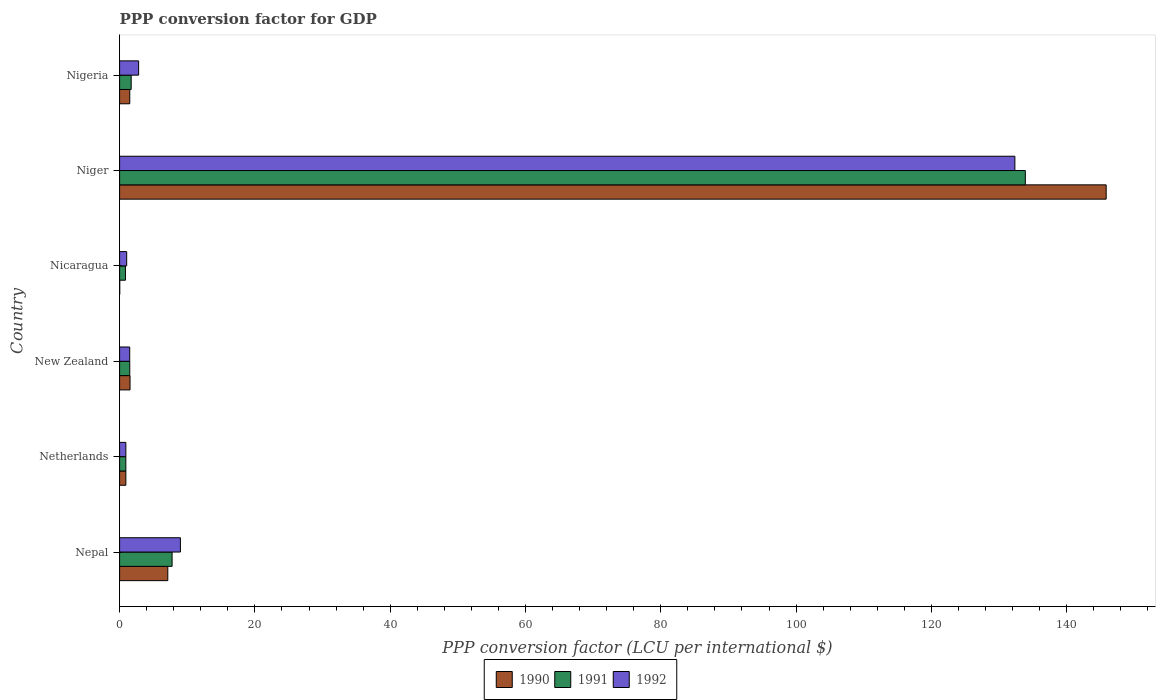How many different coloured bars are there?
Provide a short and direct response. 3. How many groups of bars are there?
Provide a succinct answer. 6. Are the number of bars on each tick of the Y-axis equal?
Keep it short and to the point. Yes. How many bars are there on the 2nd tick from the top?
Provide a short and direct response. 3. What is the label of the 2nd group of bars from the top?
Your answer should be compact. Niger. In how many cases, is the number of bars for a given country not equal to the number of legend labels?
Give a very brief answer. 0. What is the PPP conversion factor for GDP in 1992 in Nicaragua?
Give a very brief answer. 1.05. Across all countries, what is the maximum PPP conversion factor for GDP in 1990?
Provide a succinct answer. 145.83. Across all countries, what is the minimum PPP conversion factor for GDP in 1990?
Give a very brief answer. 0.02. In which country was the PPP conversion factor for GDP in 1991 maximum?
Your answer should be very brief. Niger. In which country was the PPP conversion factor for GDP in 1991 minimum?
Give a very brief answer. Nicaragua. What is the total PPP conversion factor for GDP in 1992 in the graph?
Keep it short and to the point. 147.6. What is the difference between the PPP conversion factor for GDP in 1991 in Niger and that in Nigeria?
Ensure brevity in your answer.  132.17. What is the difference between the PPP conversion factor for GDP in 1992 in New Zealand and the PPP conversion factor for GDP in 1990 in Nigeria?
Your answer should be compact. -0.01. What is the average PPP conversion factor for GDP in 1991 per country?
Keep it short and to the point. 24.44. What is the difference between the PPP conversion factor for GDP in 1991 and PPP conversion factor for GDP in 1990 in Nepal?
Your response must be concise. 0.64. In how many countries, is the PPP conversion factor for GDP in 1992 greater than 108 LCU?
Your response must be concise. 1. What is the ratio of the PPP conversion factor for GDP in 1992 in Nepal to that in New Zealand?
Ensure brevity in your answer.  6.02. Is the difference between the PPP conversion factor for GDP in 1991 in New Zealand and Niger greater than the difference between the PPP conversion factor for GDP in 1990 in New Zealand and Niger?
Your answer should be compact. Yes. What is the difference between the highest and the second highest PPP conversion factor for GDP in 1991?
Your response must be concise. 126.12. What is the difference between the highest and the lowest PPP conversion factor for GDP in 1992?
Your answer should be compact. 131.42. What does the 3rd bar from the top in Netherlands represents?
Give a very brief answer. 1990. How many bars are there?
Your answer should be very brief. 18. Are all the bars in the graph horizontal?
Make the answer very short. Yes. Are the values on the major ticks of X-axis written in scientific E-notation?
Give a very brief answer. No. Does the graph contain any zero values?
Give a very brief answer. No. Does the graph contain grids?
Offer a very short reply. No. How many legend labels are there?
Provide a succinct answer. 3. What is the title of the graph?
Offer a very short reply. PPP conversion factor for GDP. Does "1961" appear as one of the legend labels in the graph?
Your answer should be compact. No. What is the label or title of the X-axis?
Make the answer very short. PPP conversion factor (LCU per international $). What is the PPP conversion factor (LCU per international $) of 1990 in Nepal?
Provide a short and direct response. 7.12. What is the PPP conversion factor (LCU per international $) of 1991 in Nepal?
Keep it short and to the point. 7.76. What is the PPP conversion factor (LCU per international $) in 1992 in Nepal?
Keep it short and to the point. 8.99. What is the PPP conversion factor (LCU per international $) in 1990 in Netherlands?
Provide a short and direct response. 0.92. What is the PPP conversion factor (LCU per international $) of 1991 in Netherlands?
Offer a very short reply. 0.92. What is the PPP conversion factor (LCU per international $) in 1992 in Netherlands?
Provide a succinct answer. 0.92. What is the PPP conversion factor (LCU per international $) in 1990 in New Zealand?
Your response must be concise. 1.54. What is the PPP conversion factor (LCU per international $) in 1991 in New Zealand?
Offer a very short reply. 1.5. What is the PPP conversion factor (LCU per international $) in 1992 in New Zealand?
Offer a very short reply. 1.49. What is the PPP conversion factor (LCU per international $) of 1990 in Nicaragua?
Give a very brief answer. 0.02. What is the PPP conversion factor (LCU per international $) in 1991 in Nicaragua?
Ensure brevity in your answer.  0.87. What is the PPP conversion factor (LCU per international $) of 1992 in Nicaragua?
Ensure brevity in your answer.  1.05. What is the PPP conversion factor (LCU per international $) of 1990 in Niger?
Give a very brief answer. 145.83. What is the PPP conversion factor (LCU per international $) of 1991 in Niger?
Your response must be concise. 133.88. What is the PPP conversion factor (LCU per international $) of 1992 in Niger?
Your answer should be compact. 132.34. What is the PPP conversion factor (LCU per international $) of 1990 in Nigeria?
Give a very brief answer. 1.5. What is the PPP conversion factor (LCU per international $) of 1991 in Nigeria?
Your answer should be very brief. 1.71. What is the PPP conversion factor (LCU per international $) of 1992 in Nigeria?
Provide a succinct answer. 2.81. Across all countries, what is the maximum PPP conversion factor (LCU per international $) of 1990?
Your answer should be very brief. 145.83. Across all countries, what is the maximum PPP conversion factor (LCU per international $) in 1991?
Your response must be concise. 133.88. Across all countries, what is the maximum PPP conversion factor (LCU per international $) of 1992?
Make the answer very short. 132.34. Across all countries, what is the minimum PPP conversion factor (LCU per international $) of 1990?
Offer a terse response. 0.02. Across all countries, what is the minimum PPP conversion factor (LCU per international $) of 1991?
Provide a short and direct response. 0.87. Across all countries, what is the minimum PPP conversion factor (LCU per international $) of 1992?
Make the answer very short. 0.92. What is the total PPP conversion factor (LCU per international $) in 1990 in the graph?
Your response must be concise. 156.95. What is the total PPP conversion factor (LCU per international $) in 1991 in the graph?
Offer a terse response. 146.64. What is the total PPP conversion factor (LCU per international $) in 1992 in the graph?
Make the answer very short. 147.6. What is the difference between the PPP conversion factor (LCU per international $) in 1990 in Nepal and that in Netherlands?
Your response must be concise. 6.2. What is the difference between the PPP conversion factor (LCU per international $) in 1991 in Nepal and that in Netherlands?
Your response must be concise. 6.84. What is the difference between the PPP conversion factor (LCU per international $) in 1992 in Nepal and that in Netherlands?
Keep it short and to the point. 8.07. What is the difference between the PPP conversion factor (LCU per international $) of 1990 in Nepal and that in New Zealand?
Make the answer very short. 5.58. What is the difference between the PPP conversion factor (LCU per international $) of 1991 in Nepal and that in New Zealand?
Keep it short and to the point. 6.26. What is the difference between the PPP conversion factor (LCU per international $) in 1992 in Nepal and that in New Zealand?
Your response must be concise. 7.49. What is the difference between the PPP conversion factor (LCU per international $) of 1990 in Nepal and that in Nicaragua?
Make the answer very short. 7.1. What is the difference between the PPP conversion factor (LCU per international $) in 1991 in Nepal and that in Nicaragua?
Provide a short and direct response. 6.89. What is the difference between the PPP conversion factor (LCU per international $) of 1992 in Nepal and that in Nicaragua?
Offer a terse response. 7.94. What is the difference between the PPP conversion factor (LCU per international $) of 1990 in Nepal and that in Niger?
Your answer should be compact. -138.71. What is the difference between the PPP conversion factor (LCU per international $) of 1991 in Nepal and that in Niger?
Provide a succinct answer. -126.12. What is the difference between the PPP conversion factor (LCU per international $) of 1992 in Nepal and that in Niger?
Your answer should be very brief. -123.35. What is the difference between the PPP conversion factor (LCU per international $) of 1990 in Nepal and that in Nigeria?
Keep it short and to the point. 5.62. What is the difference between the PPP conversion factor (LCU per international $) of 1991 in Nepal and that in Nigeria?
Give a very brief answer. 6.05. What is the difference between the PPP conversion factor (LCU per international $) of 1992 in Nepal and that in Nigeria?
Your answer should be compact. 6.18. What is the difference between the PPP conversion factor (LCU per international $) in 1990 in Netherlands and that in New Zealand?
Ensure brevity in your answer.  -0.62. What is the difference between the PPP conversion factor (LCU per international $) of 1991 in Netherlands and that in New Zealand?
Offer a terse response. -0.58. What is the difference between the PPP conversion factor (LCU per international $) of 1992 in Netherlands and that in New Zealand?
Your response must be concise. -0.57. What is the difference between the PPP conversion factor (LCU per international $) of 1990 in Netherlands and that in Nicaragua?
Give a very brief answer. 0.9. What is the difference between the PPP conversion factor (LCU per international $) of 1991 in Netherlands and that in Nicaragua?
Your response must be concise. 0.06. What is the difference between the PPP conversion factor (LCU per international $) of 1992 in Netherlands and that in Nicaragua?
Your answer should be compact. -0.12. What is the difference between the PPP conversion factor (LCU per international $) of 1990 in Netherlands and that in Niger?
Give a very brief answer. -144.91. What is the difference between the PPP conversion factor (LCU per international $) in 1991 in Netherlands and that in Niger?
Offer a terse response. -132.96. What is the difference between the PPP conversion factor (LCU per international $) in 1992 in Netherlands and that in Niger?
Your response must be concise. -131.42. What is the difference between the PPP conversion factor (LCU per international $) in 1990 in Netherlands and that in Nigeria?
Offer a terse response. -0.58. What is the difference between the PPP conversion factor (LCU per international $) in 1991 in Netherlands and that in Nigeria?
Provide a succinct answer. -0.79. What is the difference between the PPP conversion factor (LCU per international $) in 1992 in Netherlands and that in Nigeria?
Your response must be concise. -1.89. What is the difference between the PPP conversion factor (LCU per international $) of 1990 in New Zealand and that in Nicaragua?
Provide a short and direct response. 1.52. What is the difference between the PPP conversion factor (LCU per international $) of 1991 in New Zealand and that in Nicaragua?
Keep it short and to the point. 0.64. What is the difference between the PPP conversion factor (LCU per international $) in 1992 in New Zealand and that in Nicaragua?
Your response must be concise. 0.45. What is the difference between the PPP conversion factor (LCU per international $) in 1990 in New Zealand and that in Niger?
Give a very brief answer. -144.29. What is the difference between the PPP conversion factor (LCU per international $) in 1991 in New Zealand and that in Niger?
Offer a terse response. -132.38. What is the difference between the PPP conversion factor (LCU per international $) in 1992 in New Zealand and that in Niger?
Your answer should be compact. -130.85. What is the difference between the PPP conversion factor (LCU per international $) of 1990 in New Zealand and that in Nigeria?
Your answer should be very brief. 0.04. What is the difference between the PPP conversion factor (LCU per international $) of 1991 in New Zealand and that in Nigeria?
Ensure brevity in your answer.  -0.21. What is the difference between the PPP conversion factor (LCU per international $) in 1992 in New Zealand and that in Nigeria?
Your response must be concise. -1.32. What is the difference between the PPP conversion factor (LCU per international $) of 1990 in Nicaragua and that in Niger?
Your response must be concise. -145.81. What is the difference between the PPP conversion factor (LCU per international $) in 1991 in Nicaragua and that in Niger?
Give a very brief answer. -133.02. What is the difference between the PPP conversion factor (LCU per international $) of 1992 in Nicaragua and that in Niger?
Offer a terse response. -131.29. What is the difference between the PPP conversion factor (LCU per international $) of 1990 in Nicaragua and that in Nigeria?
Provide a succinct answer. -1.48. What is the difference between the PPP conversion factor (LCU per international $) in 1991 in Nicaragua and that in Nigeria?
Keep it short and to the point. -0.85. What is the difference between the PPP conversion factor (LCU per international $) in 1992 in Nicaragua and that in Nigeria?
Your response must be concise. -1.77. What is the difference between the PPP conversion factor (LCU per international $) in 1990 in Niger and that in Nigeria?
Provide a short and direct response. 144.33. What is the difference between the PPP conversion factor (LCU per international $) in 1991 in Niger and that in Nigeria?
Your answer should be very brief. 132.17. What is the difference between the PPP conversion factor (LCU per international $) in 1992 in Niger and that in Nigeria?
Make the answer very short. 129.53. What is the difference between the PPP conversion factor (LCU per international $) in 1990 in Nepal and the PPP conversion factor (LCU per international $) in 1991 in Netherlands?
Offer a terse response. 6.2. What is the difference between the PPP conversion factor (LCU per international $) of 1990 in Nepal and the PPP conversion factor (LCU per international $) of 1992 in Netherlands?
Provide a succinct answer. 6.2. What is the difference between the PPP conversion factor (LCU per international $) of 1991 in Nepal and the PPP conversion factor (LCU per international $) of 1992 in Netherlands?
Your response must be concise. 6.84. What is the difference between the PPP conversion factor (LCU per international $) of 1990 in Nepal and the PPP conversion factor (LCU per international $) of 1991 in New Zealand?
Make the answer very short. 5.62. What is the difference between the PPP conversion factor (LCU per international $) in 1990 in Nepal and the PPP conversion factor (LCU per international $) in 1992 in New Zealand?
Your answer should be compact. 5.63. What is the difference between the PPP conversion factor (LCU per international $) of 1991 in Nepal and the PPP conversion factor (LCU per international $) of 1992 in New Zealand?
Ensure brevity in your answer.  6.26. What is the difference between the PPP conversion factor (LCU per international $) of 1990 in Nepal and the PPP conversion factor (LCU per international $) of 1991 in Nicaragua?
Your answer should be very brief. 6.26. What is the difference between the PPP conversion factor (LCU per international $) in 1990 in Nepal and the PPP conversion factor (LCU per international $) in 1992 in Nicaragua?
Your response must be concise. 6.08. What is the difference between the PPP conversion factor (LCU per international $) of 1991 in Nepal and the PPP conversion factor (LCU per international $) of 1992 in Nicaragua?
Your answer should be very brief. 6.71. What is the difference between the PPP conversion factor (LCU per international $) in 1990 in Nepal and the PPP conversion factor (LCU per international $) in 1991 in Niger?
Ensure brevity in your answer.  -126.76. What is the difference between the PPP conversion factor (LCU per international $) of 1990 in Nepal and the PPP conversion factor (LCU per international $) of 1992 in Niger?
Provide a short and direct response. -125.22. What is the difference between the PPP conversion factor (LCU per international $) of 1991 in Nepal and the PPP conversion factor (LCU per international $) of 1992 in Niger?
Give a very brief answer. -124.58. What is the difference between the PPP conversion factor (LCU per international $) in 1990 in Nepal and the PPP conversion factor (LCU per international $) in 1991 in Nigeria?
Offer a terse response. 5.41. What is the difference between the PPP conversion factor (LCU per international $) in 1990 in Nepal and the PPP conversion factor (LCU per international $) in 1992 in Nigeria?
Provide a succinct answer. 4.31. What is the difference between the PPP conversion factor (LCU per international $) of 1991 in Nepal and the PPP conversion factor (LCU per international $) of 1992 in Nigeria?
Provide a short and direct response. 4.95. What is the difference between the PPP conversion factor (LCU per international $) in 1990 in Netherlands and the PPP conversion factor (LCU per international $) in 1991 in New Zealand?
Provide a succinct answer. -0.58. What is the difference between the PPP conversion factor (LCU per international $) in 1990 in Netherlands and the PPP conversion factor (LCU per international $) in 1992 in New Zealand?
Give a very brief answer. -0.57. What is the difference between the PPP conversion factor (LCU per international $) of 1991 in Netherlands and the PPP conversion factor (LCU per international $) of 1992 in New Zealand?
Your response must be concise. -0.57. What is the difference between the PPP conversion factor (LCU per international $) of 1990 in Netherlands and the PPP conversion factor (LCU per international $) of 1991 in Nicaragua?
Provide a short and direct response. 0.06. What is the difference between the PPP conversion factor (LCU per international $) of 1990 in Netherlands and the PPP conversion factor (LCU per international $) of 1992 in Nicaragua?
Provide a succinct answer. -0.12. What is the difference between the PPP conversion factor (LCU per international $) of 1991 in Netherlands and the PPP conversion factor (LCU per international $) of 1992 in Nicaragua?
Your answer should be very brief. -0.13. What is the difference between the PPP conversion factor (LCU per international $) of 1990 in Netherlands and the PPP conversion factor (LCU per international $) of 1991 in Niger?
Offer a terse response. -132.96. What is the difference between the PPP conversion factor (LCU per international $) of 1990 in Netherlands and the PPP conversion factor (LCU per international $) of 1992 in Niger?
Your answer should be very brief. -131.42. What is the difference between the PPP conversion factor (LCU per international $) of 1991 in Netherlands and the PPP conversion factor (LCU per international $) of 1992 in Niger?
Give a very brief answer. -131.42. What is the difference between the PPP conversion factor (LCU per international $) of 1990 in Netherlands and the PPP conversion factor (LCU per international $) of 1991 in Nigeria?
Give a very brief answer. -0.79. What is the difference between the PPP conversion factor (LCU per international $) in 1990 in Netherlands and the PPP conversion factor (LCU per international $) in 1992 in Nigeria?
Provide a succinct answer. -1.89. What is the difference between the PPP conversion factor (LCU per international $) in 1991 in Netherlands and the PPP conversion factor (LCU per international $) in 1992 in Nigeria?
Make the answer very short. -1.89. What is the difference between the PPP conversion factor (LCU per international $) in 1990 in New Zealand and the PPP conversion factor (LCU per international $) in 1991 in Nicaragua?
Make the answer very short. 0.68. What is the difference between the PPP conversion factor (LCU per international $) in 1990 in New Zealand and the PPP conversion factor (LCU per international $) in 1992 in Nicaragua?
Offer a very short reply. 0.5. What is the difference between the PPP conversion factor (LCU per international $) of 1991 in New Zealand and the PPP conversion factor (LCU per international $) of 1992 in Nicaragua?
Provide a short and direct response. 0.46. What is the difference between the PPP conversion factor (LCU per international $) in 1990 in New Zealand and the PPP conversion factor (LCU per international $) in 1991 in Niger?
Your answer should be compact. -132.34. What is the difference between the PPP conversion factor (LCU per international $) of 1990 in New Zealand and the PPP conversion factor (LCU per international $) of 1992 in Niger?
Your answer should be compact. -130.8. What is the difference between the PPP conversion factor (LCU per international $) in 1991 in New Zealand and the PPP conversion factor (LCU per international $) in 1992 in Niger?
Your answer should be very brief. -130.84. What is the difference between the PPP conversion factor (LCU per international $) in 1990 in New Zealand and the PPP conversion factor (LCU per international $) in 1991 in Nigeria?
Your answer should be very brief. -0.17. What is the difference between the PPP conversion factor (LCU per international $) of 1990 in New Zealand and the PPP conversion factor (LCU per international $) of 1992 in Nigeria?
Your answer should be very brief. -1.27. What is the difference between the PPP conversion factor (LCU per international $) in 1991 in New Zealand and the PPP conversion factor (LCU per international $) in 1992 in Nigeria?
Offer a terse response. -1.31. What is the difference between the PPP conversion factor (LCU per international $) in 1990 in Nicaragua and the PPP conversion factor (LCU per international $) in 1991 in Niger?
Offer a very short reply. -133.86. What is the difference between the PPP conversion factor (LCU per international $) in 1990 in Nicaragua and the PPP conversion factor (LCU per international $) in 1992 in Niger?
Provide a short and direct response. -132.32. What is the difference between the PPP conversion factor (LCU per international $) of 1991 in Nicaragua and the PPP conversion factor (LCU per international $) of 1992 in Niger?
Keep it short and to the point. -131.47. What is the difference between the PPP conversion factor (LCU per international $) in 1990 in Nicaragua and the PPP conversion factor (LCU per international $) in 1991 in Nigeria?
Provide a short and direct response. -1.69. What is the difference between the PPP conversion factor (LCU per international $) of 1990 in Nicaragua and the PPP conversion factor (LCU per international $) of 1992 in Nigeria?
Make the answer very short. -2.79. What is the difference between the PPP conversion factor (LCU per international $) of 1991 in Nicaragua and the PPP conversion factor (LCU per international $) of 1992 in Nigeria?
Give a very brief answer. -1.95. What is the difference between the PPP conversion factor (LCU per international $) in 1990 in Niger and the PPP conversion factor (LCU per international $) in 1991 in Nigeria?
Offer a terse response. 144.12. What is the difference between the PPP conversion factor (LCU per international $) of 1990 in Niger and the PPP conversion factor (LCU per international $) of 1992 in Nigeria?
Your response must be concise. 143.02. What is the difference between the PPP conversion factor (LCU per international $) in 1991 in Niger and the PPP conversion factor (LCU per international $) in 1992 in Nigeria?
Offer a very short reply. 131.07. What is the average PPP conversion factor (LCU per international $) of 1990 per country?
Ensure brevity in your answer.  26.16. What is the average PPP conversion factor (LCU per international $) of 1991 per country?
Provide a short and direct response. 24.44. What is the average PPP conversion factor (LCU per international $) of 1992 per country?
Make the answer very short. 24.6. What is the difference between the PPP conversion factor (LCU per international $) of 1990 and PPP conversion factor (LCU per international $) of 1991 in Nepal?
Provide a succinct answer. -0.64. What is the difference between the PPP conversion factor (LCU per international $) in 1990 and PPP conversion factor (LCU per international $) in 1992 in Nepal?
Your answer should be compact. -1.87. What is the difference between the PPP conversion factor (LCU per international $) in 1991 and PPP conversion factor (LCU per international $) in 1992 in Nepal?
Offer a very short reply. -1.23. What is the difference between the PPP conversion factor (LCU per international $) of 1990 and PPP conversion factor (LCU per international $) of 1991 in Netherlands?
Provide a short and direct response. 0. What is the difference between the PPP conversion factor (LCU per international $) in 1990 and PPP conversion factor (LCU per international $) in 1992 in Netherlands?
Provide a succinct answer. -0. What is the difference between the PPP conversion factor (LCU per international $) of 1991 and PPP conversion factor (LCU per international $) of 1992 in Netherlands?
Your response must be concise. -0. What is the difference between the PPP conversion factor (LCU per international $) in 1990 and PPP conversion factor (LCU per international $) in 1991 in New Zealand?
Provide a short and direct response. 0.04. What is the difference between the PPP conversion factor (LCU per international $) of 1990 and PPP conversion factor (LCU per international $) of 1992 in New Zealand?
Ensure brevity in your answer.  0.05. What is the difference between the PPP conversion factor (LCU per international $) in 1991 and PPP conversion factor (LCU per international $) in 1992 in New Zealand?
Offer a terse response. 0.01. What is the difference between the PPP conversion factor (LCU per international $) in 1990 and PPP conversion factor (LCU per international $) in 1991 in Nicaragua?
Offer a terse response. -0.85. What is the difference between the PPP conversion factor (LCU per international $) in 1990 and PPP conversion factor (LCU per international $) in 1992 in Nicaragua?
Offer a very short reply. -1.03. What is the difference between the PPP conversion factor (LCU per international $) in 1991 and PPP conversion factor (LCU per international $) in 1992 in Nicaragua?
Offer a terse response. -0.18. What is the difference between the PPP conversion factor (LCU per international $) in 1990 and PPP conversion factor (LCU per international $) in 1991 in Niger?
Keep it short and to the point. 11.95. What is the difference between the PPP conversion factor (LCU per international $) of 1990 and PPP conversion factor (LCU per international $) of 1992 in Niger?
Offer a terse response. 13.49. What is the difference between the PPP conversion factor (LCU per international $) in 1991 and PPP conversion factor (LCU per international $) in 1992 in Niger?
Offer a terse response. 1.54. What is the difference between the PPP conversion factor (LCU per international $) in 1990 and PPP conversion factor (LCU per international $) in 1991 in Nigeria?
Provide a short and direct response. -0.21. What is the difference between the PPP conversion factor (LCU per international $) in 1990 and PPP conversion factor (LCU per international $) in 1992 in Nigeria?
Ensure brevity in your answer.  -1.31. What is the difference between the PPP conversion factor (LCU per international $) in 1991 and PPP conversion factor (LCU per international $) in 1992 in Nigeria?
Offer a very short reply. -1.1. What is the ratio of the PPP conversion factor (LCU per international $) in 1990 in Nepal to that in Netherlands?
Keep it short and to the point. 7.72. What is the ratio of the PPP conversion factor (LCU per international $) of 1991 in Nepal to that in Netherlands?
Your answer should be compact. 8.42. What is the ratio of the PPP conversion factor (LCU per international $) in 1992 in Nepal to that in Netherlands?
Provide a succinct answer. 9.74. What is the ratio of the PPP conversion factor (LCU per international $) in 1990 in Nepal to that in New Zealand?
Your response must be concise. 4.62. What is the ratio of the PPP conversion factor (LCU per international $) of 1991 in Nepal to that in New Zealand?
Offer a very short reply. 5.16. What is the ratio of the PPP conversion factor (LCU per international $) of 1992 in Nepal to that in New Zealand?
Your answer should be very brief. 6.02. What is the ratio of the PPP conversion factor (LCU per international $) in 1990 in Nepal to that in Nicaragua?
Make the answer very short. 368.31. What is the ratio of the PPP conversion factor (LCU per international $) in 1991 in Nepal to that in Nicaragua?
Your answer should be compact. 8.96. What is the ratio of the PPP conversion factor (LCU per international $) in 1992 in Nepal to that in Nicaragua?
Your answer should be very brief. 8.59. What is the ratio of the PPP conversion factor (LCU per international $) in 1990 in Nepal to that in Niger?
Your answer should be very brief. 0.05. What is the ratio of the PPP conversion factor (LCU per international $) of 1991 in Nepal to that in Niger?
Your answer should be very brief. 0.06. What is the ratio of the PPP conversion factor (LCU per international $) of 1992 in Nepal to that in Niger?
Offer a terse response. 0.07. What is the ratio of the PPP conversion factor (LCU per international $) of 1990 in Nepal to that in Nigeria?
Provide a succinct answer. 4.74. What is the ratio of the PPP conversion factor (LCU per international $) in 1991 in Nepal to that in Nigeria?
Keep it short and to the point. 4.53. What is the ratio of the PPP conversion factor (LCU per international $) in 1992 in Nepal to that in Nigeria?
Make the answer very short. 3.2. What is the ratio of the PPP conversion factor (LCU per international $) in 1990 in Netherlands to that in New Zealand?
Provide a succinct answer. 0.6. What is the ratio of the PPP conversion factor (LCU per international $) of 1991 in Netherlands to that in New Zealand?
Provide a succinct answer. 0.61. What is the ratio of the PPP conversion factor (LCU per international $) in 1992 in Netherlands to that in New Zealand?
Give a very brief answer. 0.62. What is the ratio of the PPP conversion factor (LCU per international $) in 1990 in Netherlands to that in Nicaragua?
Offer a very short reply. 47.73. What is the ratio of the PPP conversion factor (LCU per international $) of 1991 in Netherlands to that in Nicaragua?
Ensure brevity in your answer.  1.06. What is the ratio of the PPP conversion factor (LCU per international $) of 1992 in Netherlands to that in Nicaragua?
Your answer should be compact. 0.88. What is the ratio of the PPP conversion factor (LCU per international $) in 1990 in Netherlands to that in Niger?
Keep it short and to the point. 0.01. What is the ratio of the PPP conversion factor (LCU per international $) in 1991 in Netherlands to that in Niger?
Your answer should be very brief. 0.01. What is the ratio of the PPP conversion factor (LCU per international $) in 1992 in Netherlands to that in Niger?
Give a very brief answer. 0.01. What is the ratio of the PPP conversion factor (LCU per international $) in 1990 in Netherlands to that in Nigeria?
Provide a short and direct response. 0.61. What is the ratio of the PPP conversion factor (LCU per international $) of 1991 in Netherlands to that in Nigeria?
Make the answer very short. 0.54. What is the ratio of the PPP conversion factor (LCU per international $) of 1992 in Netherlands to that in Nigeria?
Provide a short and direct response. 0.33. What is the ratio of the PPP conversion factor (LCU per international $) in 1990 in New Zealand to that in Nicaragua?
Make the answer very short. 79.72. What is the ratio of the PPP conversion factor (LCU per international $) of 1991 in New Zealand to that in Nicaragua?
Your answer should be compact. 1.74. What is the ratio of the PPP conversion factor (LCU per international $) in 1992 in New Zealand to that in Nicaragua?
Ensure brevity in your answer.  1.43. What is the ratio of the PPP conversion factor (LCU per international $) in 1990 in New Zealand to that in Niger?
Provide a short and direct response. 0.01. What is the ratio of the PPP conversion factor (LCU per international $) in 1991 in New Zealand to that in Niger?
Provide a short and direct response. 0.01. What is the ratio of the PPP conversion factor (LCU per international $) in 1992 in New Zealand to that in Niger?
Your response must be concise. 0.01. What is the ratio of the PPP conversion factor (LCU per international $) in 1990 in New Zealand to that in Nigeria?
Your answer should be compact. 1.03. What is the ratio of the PPP conversion factor (LCU per international $) of 1991 in New Zealand to that in Nigeria?
Your answer should be very brief. 0.88. What is the ratio of the PPP conversion factor (LCU per international $) of 1992 in New Zealand to that in Nigeria?
Keep it short and to the point. 0.53. What is the ratio of the PPP conversion factor (LCU per international $) in 1991 in Nicaragua to that in Niger?
Keep it short and to the point. 0.01. What is the ratio of the PPP conversion factor (LCU per international $) of 1992 in Nicaragua to that in Niger?
Offer a terse response. 0.01. What is the ratio of the PPP conversion factor (LCU per international $) in 1990 in Nicaragua to that in Nigeria?
Provide a succinct answer. 0.01. What is the ratio of the PPP conversion factor (LCU per international $) of 1991 in Nicaragua to that in Nigeria?
Offer a terse response. 0.51. What is the ratio of the PPP conversion factor (LCU per international $) of 1992 in Nicaragua to that in Nigeria?
Your response must be concise. 0.37. What is the ratio of the PPP conversion factor (LCU per international $) in 1990 in Niger to that in Nigeria?
Keep it short and to the point. 97.01. What is the ratio of the PPP conversion factor (LCU per international $) in 1991 in Niger to that in Nigeria?
Your response must be concise. 78.25. What is the ratio of the PPP conversion factor (LCU per international $) of 1992 in Niger to that in Nigeria?
Offer a very short reply. 47.07. What is the difference between the highest and the second highest PPP conversion factor (LCU per international $) of 1990?
Provide a succinct answer. 138.71. What is the difference between the highest and the second highest PPP conversion factor (LCU per international $) of 1991?
Offer a very short reply. 126.12. What is the difference between the highest and the second highest PPP conversion factor (LCU per international $) in 1992?
Give a very brief answer. 123.35. What is the difference between the highest and the lowest PPP conversion factor (LCU per international $) of 1990?
Offer a very short reply. 145.81. What is the difference between the highest and the lowest PPP conversion factor (LCU per international $) in 1991?
Offer a very short reply. 133.02. What is the difference between the highest and the lowest PPP conversion factor (LCU per international $) in 1992?
Give a very brief answer. 131.42. 